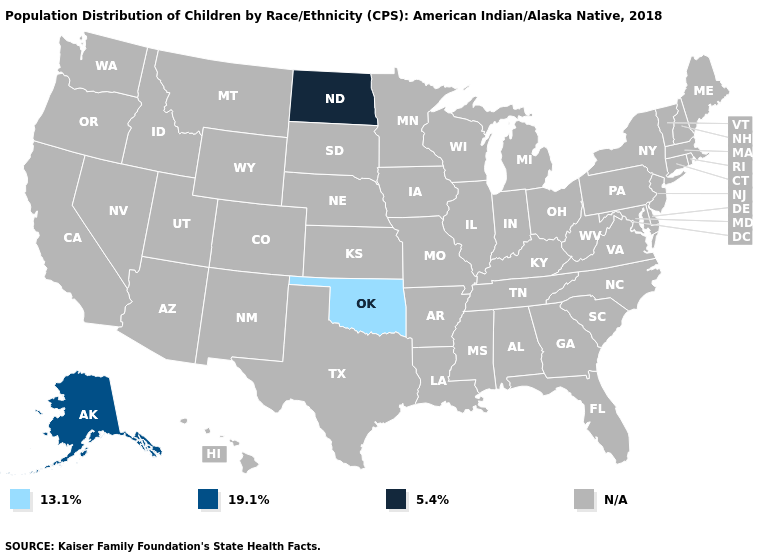Name the states that have a value in the range 5.4%?
Write a very short answer. North Dakota. Name the states that have a value in the range 19.1%?
Keep it brief. Alaska. What is the value of Colorado?
Answer briefly. N/A. What is the value of North Carolina?
Answer briefly. N/A. Name the states that have a value in the range N/A?
Write a very short answer. Alabama, Arizona, Arkansas, California, Colorado, Connecticut, Delaware, Florida, Georgia, Hawaii, Idaho, Illinois, Indiana, Iowa, Kansas, Kentucky, Louisiana, Maine, Maryland, Massachusetts, Michigan, Minnesota, Mississippi, Missouri, Montana, Nebraska, Nevada, New Hampshire, New Jersey, New Mexico, New York, North Carolina, Ohio, Oregon, Pennsylvania, Rhode Island, South Carolina, South Dakota, Tennessee, Texas, Utah, Vermont, Virginia, Washington, West Virginia, Wisconsin, Wyoming. Name the states that have a value in the range 5.4%?
Keep it brief. North Dakota. Does the first symbol in the legend represent the smallest category?
Write a very short answer. Yes. What is the lowest value in the USA?
Keep it brief. 13.1%. Which states hav the highest value in the West?
Keep it brief. Alaska. 